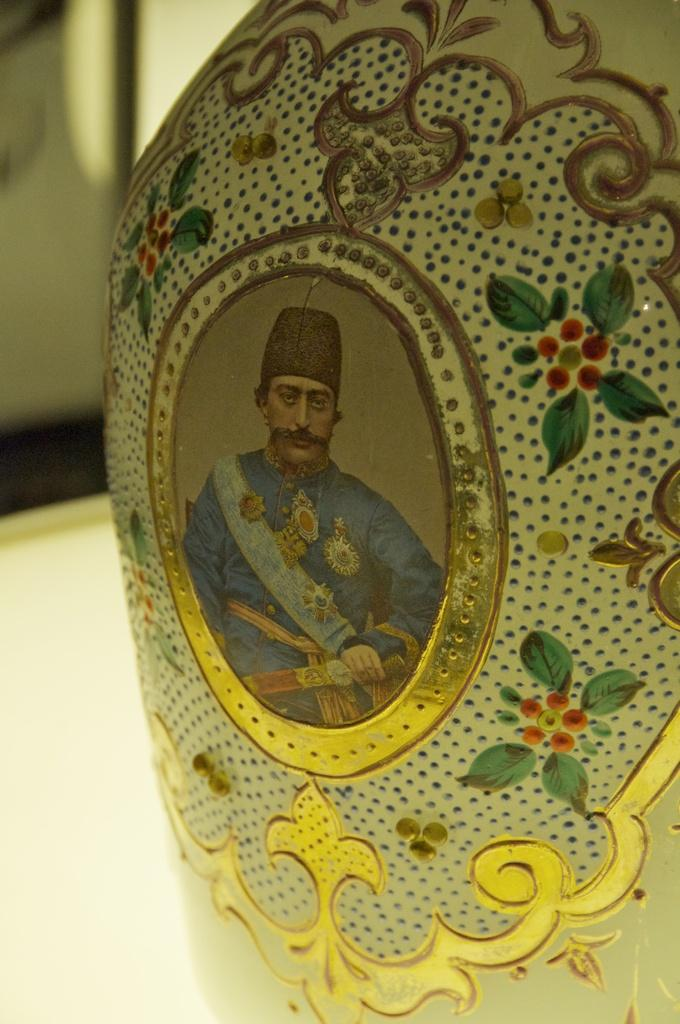What object is present in the image that holds flowers? There is a flower vase in the image. What is depicted on the vase? There is a photo of a man on the vase. How are the flowers and leaves represented on the vase? Flowers and leaves are drawn on the vase with paint. What activity is the man in the photo on the vase engaged in? The provided facts do not mention any activity that the man in the photo is engaged in. 